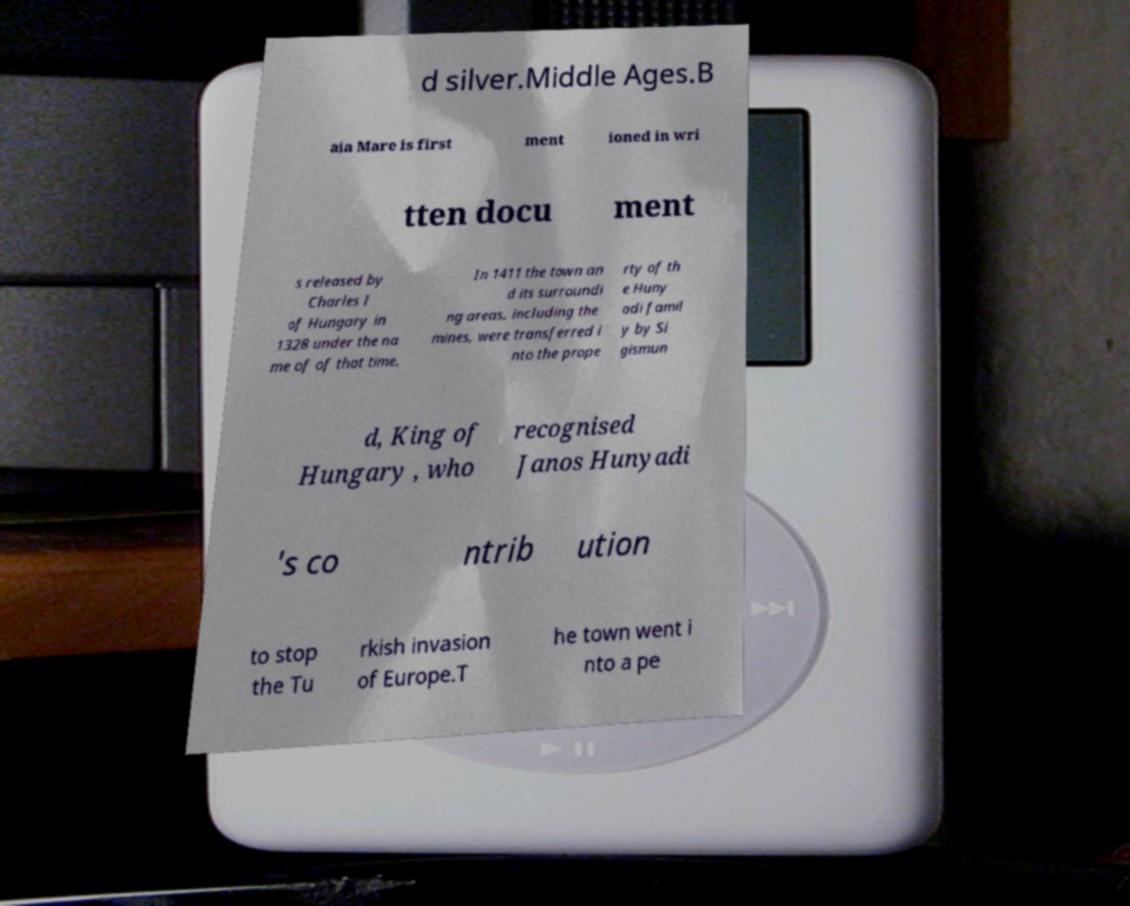Can you accurately transcribe the text from the provided image for me? d silver.Middle Ages.B aia Mare is first ment ioned in wri tten docu ment s released by Charles I of Hungary in 1328 under the na me of of that time. In 1411 the town an d its surroundi ng areas, including the mines, were transferred i nto the prope rty of th e Huny adi famil y by Si gismun d, King of Hungary , who recognised Janos Hunyadi 's co ntrib ution to stop the Tu rkish invasion of Europe.T he town went i nto a pe 